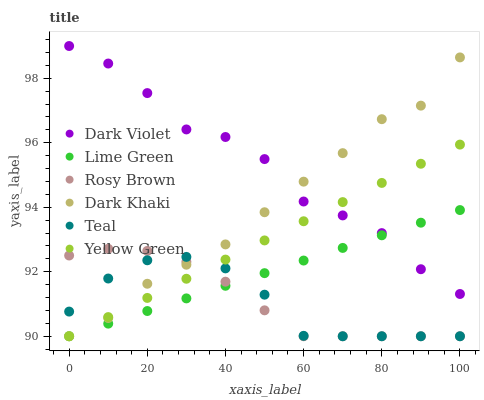Does Teal have the minimum area under the curve?
Answer yes or no. Yes. Does Dark Violet have the maximum area under the curve?
Answer yes or no. Yes. Does Rosy Brown have the minimum area under the curve?
Answer yes or no. No. Does Rosy Brown have the maximum area under the curve?
Answer yes or no. No. Is Yellow Green the smoothest?
Answer yes or no. Yes. Is Dark Violet the roughest?
Answer yes or no. Yes. Is Rosy Brown the smoothest?
Answer yes or no. No. Is Rosy Brown the roughest?
Answer yes or no. No. Does Yellow Green have the lowest value?
Answer yes or no. Yes. Does Dark Violet have the lowest value?
Answer yes or no. No. Does Dark Violet have the highest value?
Answer yes or no. Yes. Does Rosy Brown have the highest value?
Answer yes or no. No. Is Teal less than Dark Violet?
Answer yes or no. Yes. Is Dark Violet greater than Teal?
Answer yes or no. Yes. Does Dark Khaki intersect Rosy Brown?
Answer yes or no. Yes. Is Dark Khaki less than Rosy Brown?
Answer yes or no. No. Is Dark Khaki greater than Rosy Brown?
Answer yes or no. No. Does Teal intersect Dark Violet?
Answer yes or no. No. 